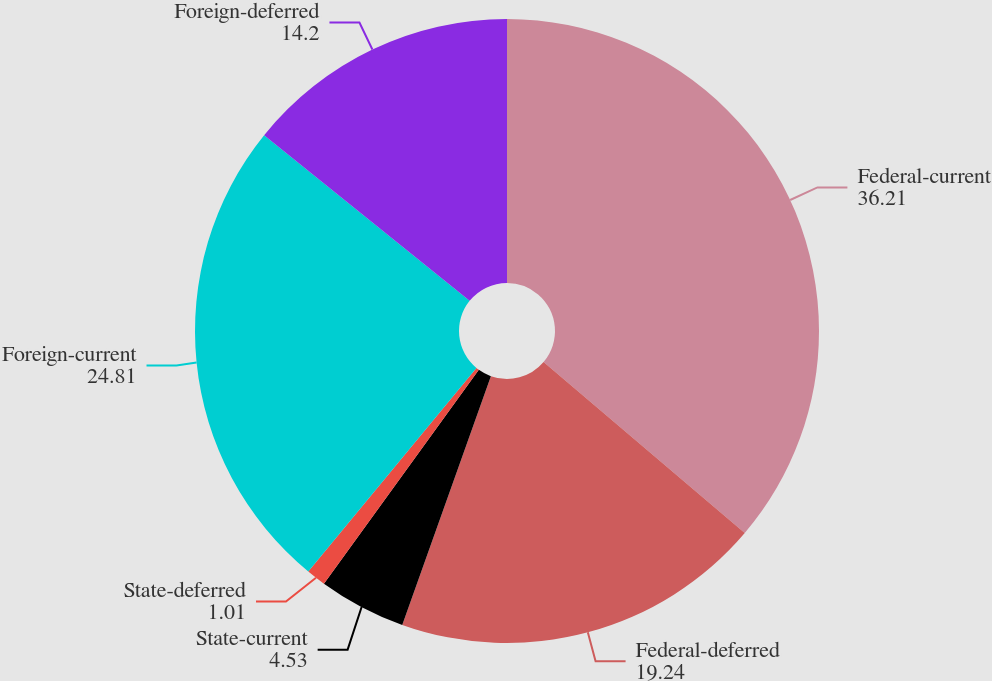<chart> <loc_0><loc_0><loc_500><loc_500><pie_chart><fcel>Federal-current<fcel>Federal-deferred<fcel>State-current<fcel>State-deferred<fcel>Foreign-current<fcel>Foreign-deferred<nl><fcel>36.21%<fcel>19.24%<fcel>4.53%<fcel>1.01%<fcel>24.81%<fcel>14.2%<nl></chart> 